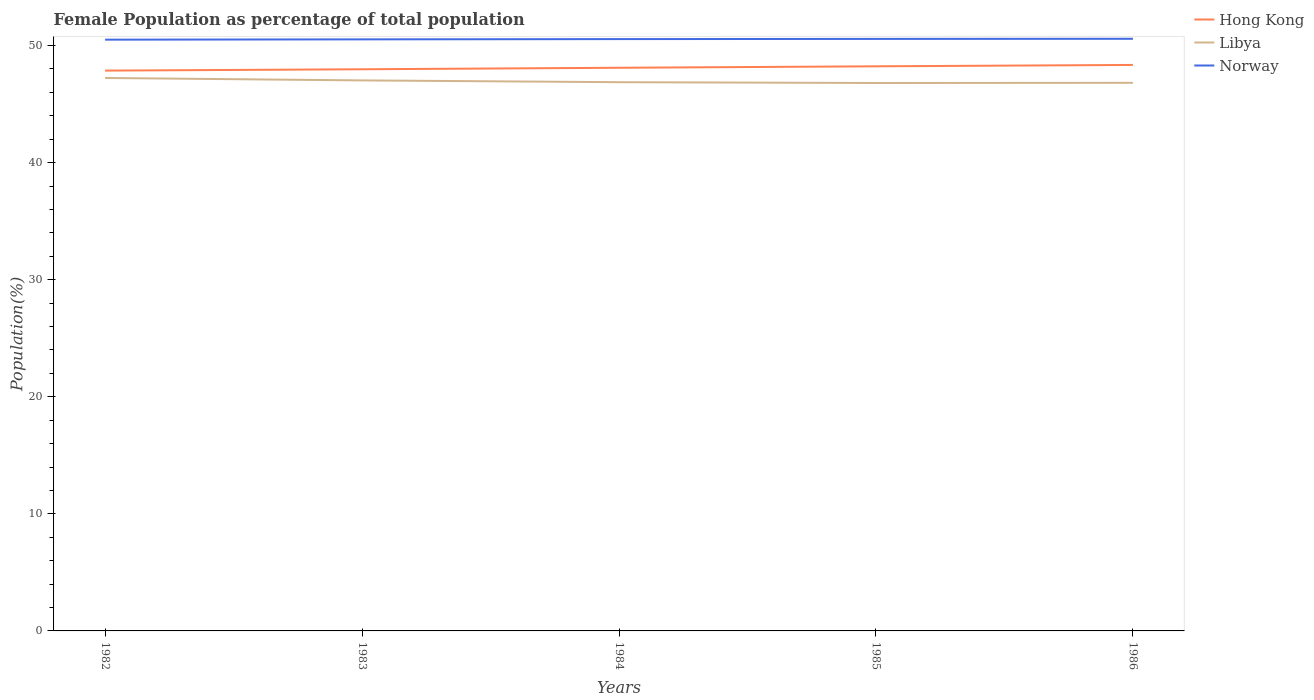How many different coloured lines are there?
Offer a very short reply. 3. Is the number of lines equal to the number of legend labels?
Offer a terse response. Yes. Across all years, what is the maximum female population in in Norway?
Provide a succinct answer. 50.5. In which year was the female population in in Libya maximum?
Your answer should be very brief. 1985. What is the total female population in in Hong Kong in the graph?
Offer a terse response. -0.12. What is the difference between the highest and the second highest female population in in Norway?
Your response must be concise. 0.07. What is the difference between the highest and the lowest female population in in Hong Kong?
Provide a succinct answer. 3. Is the female population in in Norway strictly greater than the female population in in Libya over the years?
Your answer should be very brief. No. What is the difference between two consecutive major ticks on the Y-axis?
Keep it short and to the point. 10. Does the graph contain any zero values?
Provide a succinct answer. No. How are the legend labels stacked?
Make the answer very short. Vertical. What is the title of the graph?
Your answer should be very brief. Female Population as percentage of total population. Does "West Bank and Gaza" appear as one of the legend labels in the graph?
Keep it short and to the point. No. What is the label or title of the Y-axis?
Your response must be concise. Population(%). What is the Population(%) in Hong Kong in 1982?
Provide a succinct answer. 47.86. What is the Population(%) of Libya in 1982?
Offer a very short reply. 47.23. What is the Population(%) in Norway in 1982?
Offer a very short reply. 50.5. What is the Population(%) in Hong Kong in 1983?
Make the answer very short. 47.97. What is the Population(%) of Libya in 1983?
Give a very brief answer. 47.02. What is the Population(%) in Norway in 1983?
Provide a succinct answer. 50.53. What is the Population(%) of Hong Kong in 1984?
Keep it short and to the point. 48.1. What is the Population(%) of Libya in 1984?
Give a very brief answer. 46.87. What is the Population(%) of Norway in 1984?
Your response must be concise. 50.55. What is the Population(%) in Hong Kong in 1985?
Provide a short and direct response. 48.22. What is the Population(%) of Libya in 1985?
Your answer should be compact. 46.8. What is the Population(%) in Norway in 1985?
Your response must be concise. 50.57. What is the Population(%) of Hong Kong in 1986?
Give a very brief answer. 48.34. What is the Population(%) in Libya in 1986?
Your answer should be very brief. 46.81. What is the Population(%) of Norway in 1986?
Provide a succinct answer. 50.58. Across all years, what is the maximum Population(%) in Hong Kong?
Provide a succinct answer. 48.34. Across all years, what is the maximum Population(%) of Libya?
Ensure brevity in your answer.  47.23. Across all years, what is the maximum Population(%) of Norway?
Offer a very short reply. 50.58. Across all years, what is the minimum Population(%) of Hong Kong?
Give a very brief answer. 47.86. Across all years, what is the minimum Population(%) of Libya?
Your answer should be very brief. 46.8. Across all years, what is the minimum Population(%) of Norway?
Offer a very short reply. 50.5. What is the total Population(%) of Hong Kong in the graph?
Offer a terse response. 240.5. What is the total Population(%) in Libya in the graph?
Keep it short and to the point. 234.73. What is the total Population(%) of Norway in the graph?
Offer a very short reply. 252.72. What is the difference between the Population(%) in Hong Kong in 1982 and that in 1983?
Your answer should be compact. -0.11. What is the difference between the Population(%) in Libya in 1982 and that in 1983?
Provide a short and direct response. 0.21. What is the difference between the Population(%) in Norway in 1982 and that in 1983?
Ensure brevity in your answer.  -0.03. What is the difference between the Population(%) of Hong Kong in 1982 and that in 1984?
Offer a very short reply. -0.24. What is the difference between the Population(%) of Libya in 1982 and that in 1984?
Your answer should be very brief. 0.36. What is the difference between the Population(%) in Norway in 1982 and that in 1984?
Offer a terse response. -0.05. What is the difference between the Population(%) in Hong Kong in 1982 and that in 1985?
Offer a terse response. -0.37. What is the difference between the Population(%) in Libya in 1982 and that in 1985?
Provide a short and direct response. 0.43. What is the difference between the Population(%) in Norway in 1982 and that in 1985?
Your answer should be compact. -0.06. What is the difference between the Population(%) in Hong Kong in 1982 and that in 1986?
Provide a short and direct response. -0.48. What is the difference between the Population(%) of Libya in 1982 and that in 1986?
Give a very brief answer. 0.41. What is the difference between the Population(%) in Norway in 1982 and that in 1986?
Offer a very short reply. -0.07. What is the difference between the Population(%) in Hong Kong in 1983 and that in 1984?
Give a very brief answer. -0.13. What is the difference between the Population(%) in Libya in 1983 and that in 1984?
Offer a terse response. 0.15. What is the difference between the Population(%) in Norway in 1983 and that in 1984?
Offer a terse response. -0.02. What is the difference between the Population(%) of Hong Kong in 1983 and that in 1985?
Ensure brevity in your answer.  -0.25. What is the difference between the Population(%) of Libya in 1983 and that in 1985?
Give a very brief answer. 0.22. What is the difference between the Population(%) of Norway in 1983 and that in 1985?
Your answer should be compact. -0.04. What is the difference between the Population(%) in Hong Kong in 1983 and that in 1986?
Provide a short and direct response. -0.37. What is the difference between the Population(%) in Libya in 1983 and that in 1986?
Your response must be concise. 0.21. What is the difference between the Population(%) in Norway in 1983 and that in 1986?
Your answer should be very brief. -0.05. What is the difference between the Population(%) in Hong Kong in 1984 and that in 1985?
Offer a very short reply. -0.12. What is the difference between the Population(%) in Libya in 1984 and that in 1985?
Provide a succinct answer. 0.07. What is the difference between the Population(%) in Norway in 1984 and that in 1985?
Your answer should be compact. -0.02. What is the difference between the Population(%) in Hong Kong in 1984 and that in 1986?
Your answer should be compact. -0.24. What is the difference between the Population(%) in Libya in 1984 and that in 1986?
Keep it short and to the point. 0.05. What is the difference between the Population(%) in Norway in 1984 and that in 1986?
Make the answer very short. -0.03. What is the difference between the Population(%) in Hong Kong in 1985 and that in 1986?
Keep it short and to the point. -0.12. What is the difference between the Population(%) in Libya in 1985 and that in 1986?
Give a very brief answer. -0.02. What is the difference between the Population(%) of Norway in 1985 and that in 1986?
Offer a terse response. -0.01. What is the difference between the Population(%) of Hong Kong in 1982 and the Population(%) of Libya in 1983?
Offer a terse response. 0.84. What is the difference between the Population(%) of Hong Kong in 1982 and the Population(%) of Norway in 1983?
Offer a terse response. -2.67. What is the difference between the Population(%) in Libya in 1982 and the Population(%) in Norway in 1983?
Your answer should be very brief. -3.3. What is the difference between the Population(%) in Hong Kong in 1982 and the Population(%) in Norway in 1984?
Give a very brief answer. -2.69. What is the difference between the Population(%) of Libya in 1982 and the Population(%) of Norway in 1984?
Make the answer very short. -3.32. What is the difference between the Population(%) in Hong Kong in 1982 and the Population(%) in Libya in 1985?
Your response must be concise. 1.06. What is the difference between the Population(%) of Hong Kong in 1982 and the Population(%) of Norway in 1985?
Provide a short and direct response. -2.71. What is the difference between the Population(%) in Libya in 1982 and the Population(%) in Norway in 1985?
Your answer should be very brief. -3.34. What is the difference between the Population(%) in Hong Kong in 1982 and the Population(%) in Libya in 1986?
Your answer should be compact. 1.04. What is the difference between the Population(%) in Hong Kong in 1982 and the Population(%) in Norway in 1986?
Your answer should be compact. -2.72. What is the difference between the Population(%) in Libya in 1982 and the Population(%) in Norway in 1986?
Give a very brief answer. -3.35. What is the difference between the Population(%) of Hong Kong in 1983 and the Population(%) of Libya in 1984?
Your answer should be compact. 1.1. What is the difference between the Population(%) in Hong Kong in 1983 and the Population(%) in Norway in 1984?
Offer a terse response. -2.58. What is the difference between the Population(%) of Libya in 1983 and the Population(%) of Norway in 1984?
Keep it short and to the point. -3.53. What is the difference between the Population(%) of Hong Kong in 1983 and the Population(%) of Libya in 1985?
Provide a short and direct response. 1.17. What is the difference between the Population(%) of Hong Kong in 1983 and the Population(%) of Norway in 1985?
Make the answer very short. -2.59. What is the difference between the Population(%) in Libya in 1983 and the Population(%) in Norway in 1985?
Your answer should be compact. -3.55. What is the difference between the Population(%) in Hong Kong in 1983 and the Population(%) in Libya in 1986?
Ensure brevity in your answer.  1.16. What is the difference between the Population(%) of Hong Kong in 1983 and the Population(%) of Norway in 1986?
Provide a short and direct response. -2.6. What is the difference between the Population(%) of Libya in 1983 and the Population(%) of Norway in 1986?
Provide a succinct answer. -3.56. What is the difference between the Population(%) in Hong Kong in 1984 and the Population(%) in Libya in 1985?
Your answer should be compact. 1.3. What is the difference between the Population(%) of Hong Kong in 1984 and the Population(%) of Norway in 1985?
Keep it short and to the point. -2.47. What is the difference between the Population(%) of Libya in 1984 and the Population(%) of Norway in 1985?
Give a very brief answer. -3.7. What is the difference between the Population(%) in Hong Kong in 1984 and the Population(%) in Libya in 1986?
Give a very brief answer. 1.29. What is the difference between the Population(%) of Hong Kong in 1984 and the Population(%) of Norway in 1986?
Make the answer very short. -2.48. What is the difference between the Population(%) in Libya in 1984 and the Population(%) in Norway in 1986?
Make the answer very short. -3.71. What is the difference between the Population(%) in Hong Kong in 1985 and the Population(%) in Libya in 1986?
Make the answer very short. 1.41. What is the difference between the Population(%) in Hong Kong in 1985 and the Population(%) in Norway in 1986?
Make the answer very short. -2.35. What is the difference between the Population(%) in Libya in 1985 and the Population(%) in Norway in 1986?
Make the answer very short. -3.78. What is the average Population(%) in Hong Kong per year?
Offer a terse response. 48.1. What is the average Population(%) in Libya per year?
Ensure brevity in your answer.  46.95. What is the average Population(%) in Norway per year?
Keep it short and to the point. 50.54. In the year 1982, what is the difference between the Population(%) in Hong Kong and Population(%) in Libya?
Your answer should be very brief. 0.63. In the year 1982, what is the difference between the Population(%) in Hong Kong and Population(%) in Norway?
Give a very brief answer. -2.64. In the year 1982, what is the difference between the Population(%) in Libya and Population(%) in Norway?
Ensure brevity in your answer.  -3.27. In the year 1983, what is the difference between the Population(%) of Hong Kong and Population(%) of Libya?
Offer a very short reply. 0.95. In the year 1983, what is the difference between the Population(%) of Hong Kong and Population(%) of Norway?
Ensure brevity in your answer.  -2.55. In the year 1983, what is the difference between the Population(%) of Libya and Population(%) of Norway?
Give a very brief answer. -3.51. In the year 1984, what is the difference between the Population(%) of Hong Kong and Population(%) of Libya?
Your answer should be compact. 1.23. In the year 1984, what is the difference between the Population(%) of Hong Kong and Population(%) of Norway?
Make the answer very short. -2.45. In the year 1984, what is the difference between the Population(%) in Libya and Population(%) in Norway?
Your answer should be very brief. -3.68. In the year 1985, what is the difference between the Population(%) in Hong Kong and Population(%) in Libya?
Your answer should be compact. 1.43. In the year 1985, what is the difference between the Population(%) in Hong Kong and Population(%) in Norway?
Provide a short and direct response. -2.34. In the year 1985, what is the difference between the Population(%) of Libya and Population(%) of Norway?
Ensure brevity in your answer.  -3.77. In the year 1986, what is the difference between the Population(%) of Hong Kong and Population(%) of Libya?
Your answer should be very brief. 1.53. In the year 1986, what is the difference between the Population(%) of Hong Kong and Population(%) of Norway?
Offer a terse response. -2.23. In the year 1986, what is the difference between the Population(%) of Libya and Population(%) of Norway?
Provide a short and direct response. -3.76. What is the ratio of the Population(%) in Libya in 1982 to that in 1983?
Your response must be concise. 1. What is the ratio of the Population(%) in Libya in 1982 to that in 1984?
Your answer should be very brief. 1.01. What is the ratio of the Population(%) of Norway in 1982 to that in 1984?
Ensure brevity in your answer.  1. What is the ratio of the Population(%) of Hong Kong in 1982 to that in 1985?
Your response must be concise. 0.99. What is the ratio of the Population(%) of Libya in 1982 to that in 1985?
Provide a short and direct response. 1.01. What is the ratio of the Population(%) in Libya in 1982 to that in 1986?
Your answer should be compact. 1.01. What is the ratio of the Population(%) in Libya in 1983 to that in 1984?
Your response must be concise. 1. What is the ratio of the Population(%) of Norway in 1983 to that in 1984?
Offer a very short reply. 1. What is the ratio of the Population(%) in Hong Kong in 1983 to that in 1985?
Provide a succinct answer. 0.99. What is the ratio of the Population(%) of Libya in 1983 to that in 1985?
Keep it short and to the point. 1. What is the ratio of the Population(%) of Hong Kong in 1983 to that in 1986?
Ensure brevity in your answer.  0.99. What is the ratio of the Population(%) of Libya in 1983 to that in 1986?
Your answer should be very brief. 1. What is the ratio of the Population(%) of Hong Kong in 1984 to that in 1985?
Offer a terse response. 1. What is the ratio of the Population(%) of Libya in 1984 to that in 1985?
Your response must be concise. 1. What is the ratio of the Population(%) in Norway in 1984 to that in 1985?
Your response must be concise. 1. What is the ratio of the Population(%) of Hong Kong in 1984 to that in 1986?
Your answer should be very brief. 0.99. What is the ratio of the Population(%) in Hong Kong in 1985 to that in 1986?
Keep it short and to the point. 1. What is the ratio of the Population(%) in Libya in 1985 to that in 1986?
Provide a short and direct response. 1. What is the ratio of the Population(%) of Norway in 1985 to that in 1986?
Offer a very short reply. 1. What is the difference between the highest and the second highest Population(%) of Hong Kong?
Provide a short and direct response. 0.12. What is the difference between the highest and the second highest Population(%) of Libya?
Make the answer very short. 0.21. What is the difference between the highest and the second highest Population(%) of Norway?
Your response must be concise. 0.01. What is the difference between the highest and the lowest Population(%) in Hong Kong?
Your response must be concise. 0.48. What is the difference between the highest and the lowest Population(%) in Libya?
Your response must be concise. 0.43. What is the difference between the highest and the lowest Population(%) of Norway?
Your answer should be very brief. 0.07. 